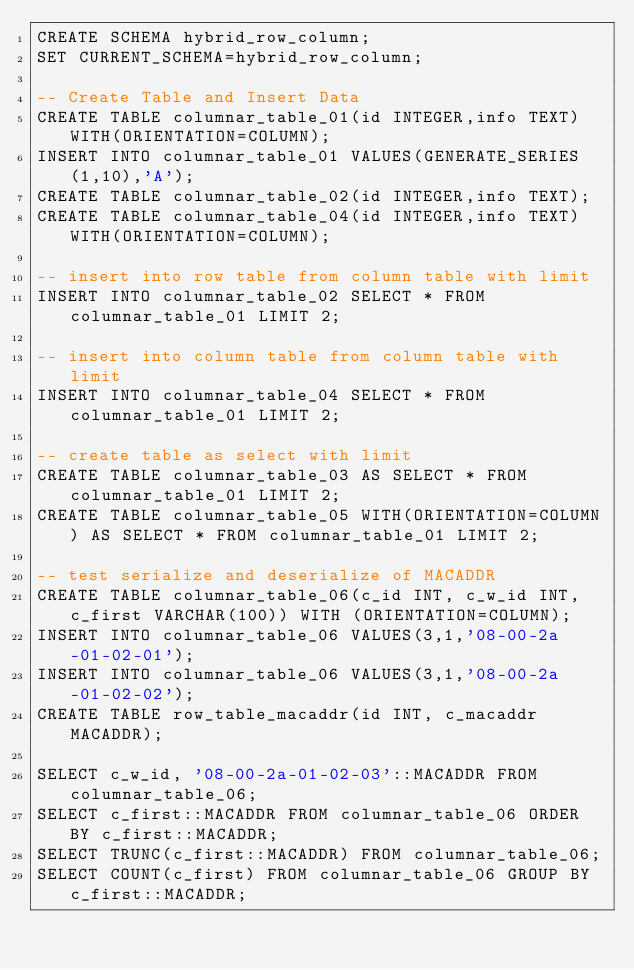Convert code to text. <code><loc_0><loc_0><loc_500><loc_500><_SQL_>CREATE SCHEMA hybrid_row_column;
SET CURRENT_SCHEMA=hybrid_row_column;

-- Create Table and Insert Data
CREATE TABLE columnar_table_01(id INTEGER,info TEXT) WITH(ORIENTATION=COLUMN);
INSERT INTO columnar_table_01 VALUES(GENERATE_SERIES(1,10),'A');
CREATE TABLE columnar_table_02(id INTEGER,info TEXT);
CREATE TABLE columnar_table_04(id INTEGER,info TEXT) WITH(ORIENTATION=COLUMN);

-- insert into row table from column table with limit
INSERT INTO columnar_table_02 SELECT * FROM columnar_table_01 LIMIT 2;

-- insert into column table from column table with limit
INSERT INTO columnar_table_04 SELECT * FROM columnar_table_01 LIMIT 2;

-- create table as select with limit
CREATE TABLE columnar_table_03 AS SELECT * FROM columnar_table_01 LIMIT 2;
CREATE TABLE columnar_table_05 WITH(ORIENTATION=COLUMN) AS SELECT * FROM columnar_table_01 LIMIT 2;

-- test serialize and deserialize of MACADDR
CREATE TABLE columnar_table_06(c_id INT, c_w_id INT, c_first VARCHAR(100)) WITH (ORIENTATION=COLUMN);
INSERT INTO columnar_table_06 VALUES(3,1,'08-00-2a-01-02-01');
INSERT INTO columnar_table_06 VALUES(3,1,'08-00-2a-01-02-02');
CREATE TABLE row_table_macaddr(id INT, c_macaddr MACADDR);

SELECT c_w_id, '08-00-2a-01-02-03'::MACADDR FROM columnar_table_06;
SELECT c_first::MACADDR FROM columnar_table_06 ORDER BY c_first::MACADDR;
SELECT TRUNC(c_first::MACADDR) FROM columnar_table_06;
SELECT COUNT(c_first) FROM columnar_table_06 GROUP BY c_first::MACADDR;</code> 